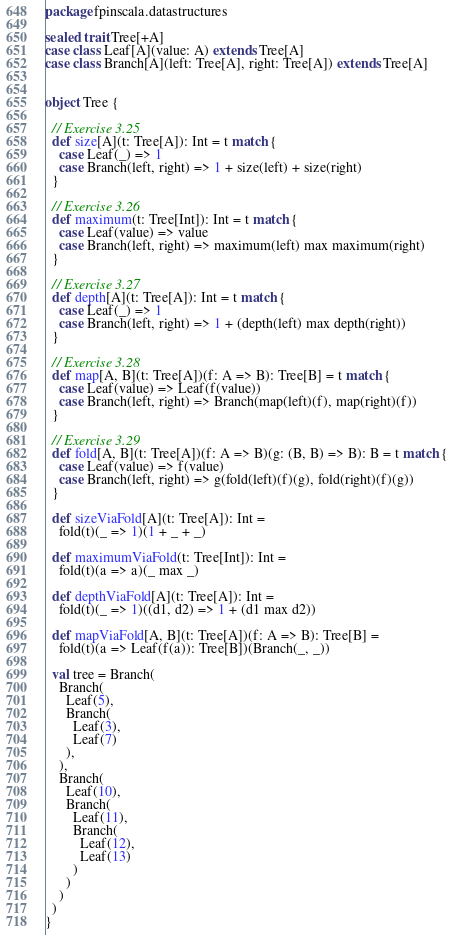Convert code to text. <code><loc_0><loc_0><loc_500><loc_500><_Scala_>package fpinscala.datastructures

sealed trait Tree[+A]
case class Leaf[A](value: A) extends Tree[A]
case class Branch[A](left: Tree[A], right: Tree[A]) extends Tree[A]


object Tree {

  // Exercise 3.25
  def size[A](t: Tree[A]): Int = t match {
    case Leaf(_) => 1
    case Branch(left, right) => 1 + size(left) + size(right)
  }

  // Exercise 3.26
  def maximum(t: Tree[Int]): Int = t match {
    case Leaf(value) => value
    case Branch(left, right) => maximum(left) max maximum(right)
  }

  // Exercise 3.27
  def depth[A](t: Tree[A]): Int = t match {
    case Leaf(_) => 1
    case Branch(left, right) => 1 + (depth(left) max depth(right))
  }

  // Exercise 3.28
  def map[A, B](t: Tree[A])(f: A => B): Tree[B] = t match {
    case Leaf(value) => Leaf(f(value))
    case Branch(left, right) => Branch(map(left)(f), map(right)(f))
  }

  // Exercise 3.29
  def fold[A, B](t: Tree[A])(f: A => B)(g: (B, B) => B): B = t match {
    case Leaf(value) => f(value)
    case Branch(left, right) => g(fold(left)(f)(g), fold(right)(f)(g))
  }

  def sizeViaFold[A](t: Tree[A]): Int =
    fold(t)(_ => 1)(1 + _ + _)

  def maximumViaFold(t: Tree[Int]): Int =
    fold(t)(a => a)(_ max _)

  def depthViaFold[A](t: Tree[A]): Int =
    fold(t)(_ => 1)((d1, d2) => 1 + (d1 max d2))

  def mapViaFold[A, B](t: Tree[A])(f: A => B): Tree[B] =
    fold(t)(a => Leaf(f(a)): Tree[B])(Branch(_, _))

  val tree = Branch(
    Branch(
      Leaf(5),
      Branch(
        Leaf(3),
        Leaf(7)
      ),
    ),
    Branch(
      Leaf(10),
      Branch(
        Leaf(11),
        Branch(
          Leaf(12),
          Leaf(13)
        )
      )
    )
  )
}</code> 